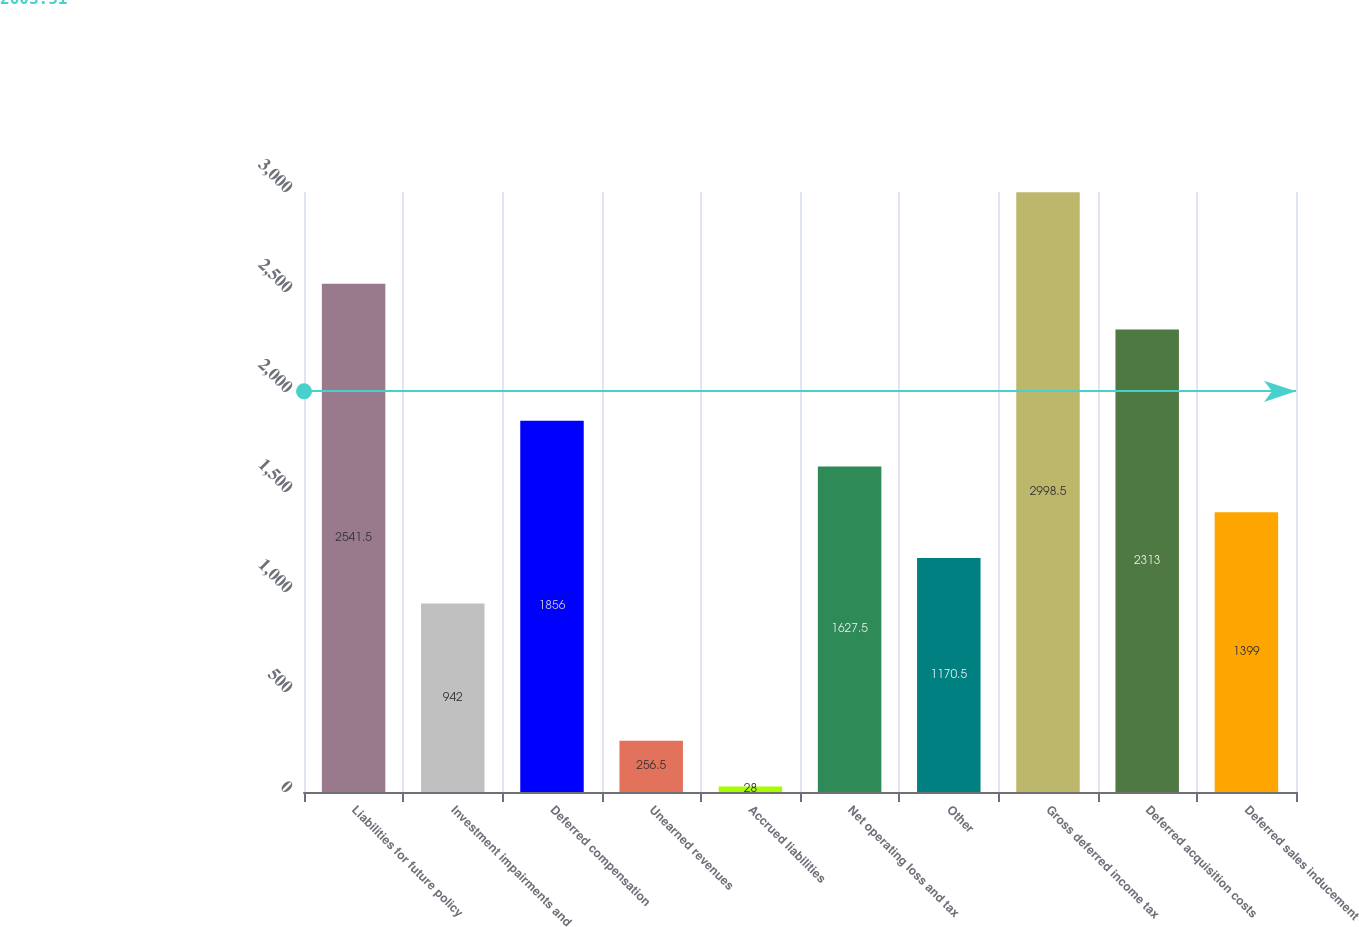<chart> <loc_0><loc_0><loc_500><loc_500><bar_chart><fcel>Liabilities for future policy<fcel>Investment impairments and<fcel>Deferred compensation<fcel>Unearned revenues<fcel>Accrued liabilities<fcel>Net operating loss and tax<fcel>Other<fcel>Gross deferred income tax<fcel>Deferred acquisition costs<fcel>Deferred sales inducement<nl><fcel>2541.5<fcel>942<fcel>1856<fcel>256.5<fcel>28<fcel>1627.5<fcel>1170.5<fcel>2998.5<fcel>2313<fcel>1399<nl></chart> 